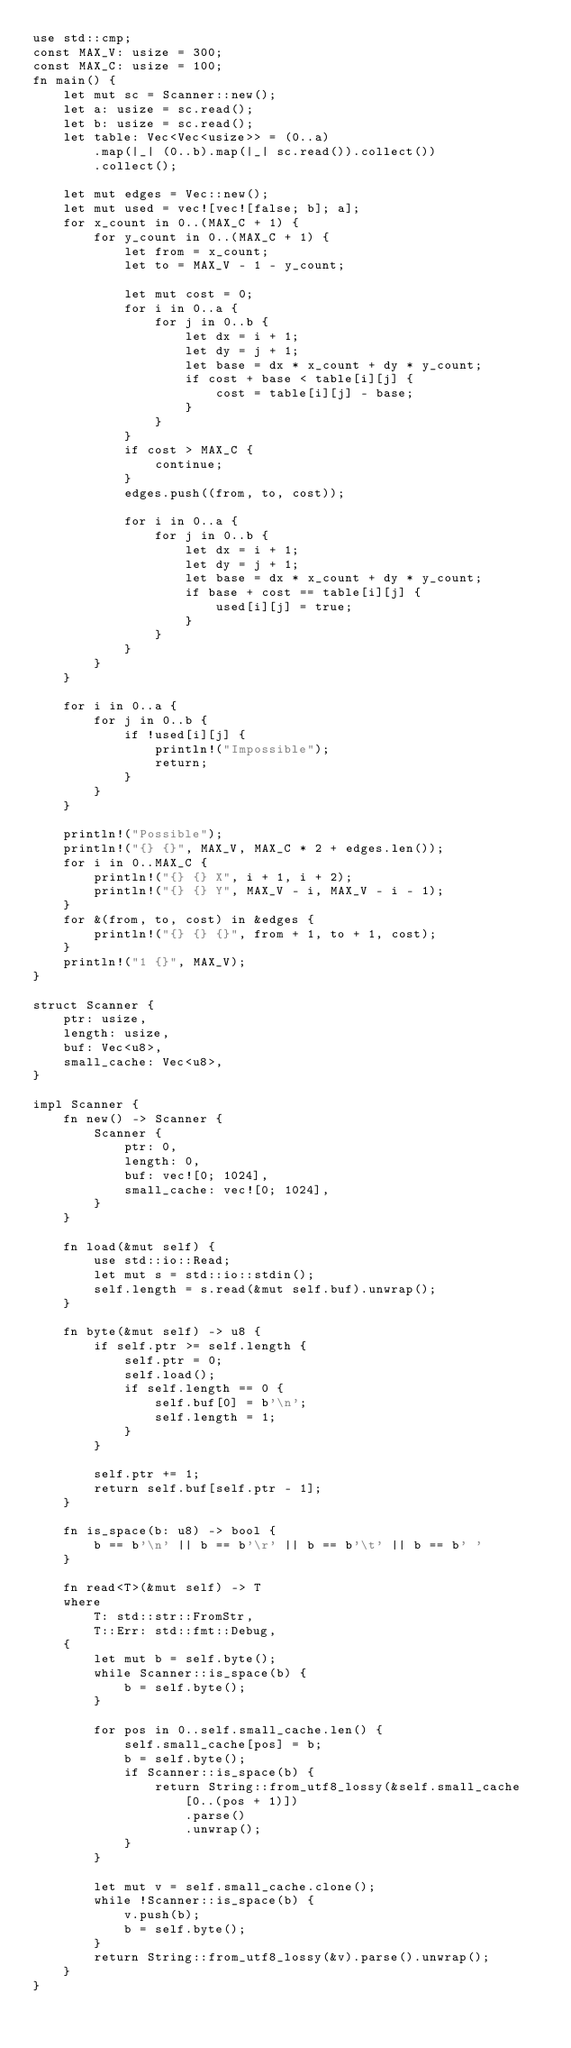Convert code to text. <code><loc_0><loc_0><loc_500><loc_500><_Rust_>use std::cmp;
const MAX_V: usize = 300;
const MAX_C: usize = 100;
fn main() {
    let mut sc = Scanner::new();
    let a: usize = sc.read();
    let b: usize = sc.read();
    let table: Vec<Vec<usize>> = (0..a)
        .map(|_| (0..b).map(|_| sc.read()).collect())
        .collect();

    let mut edges = Vec::new();
    let mut used = vec![vec![false; b]; a];
    for x_count in 0..(MAX_C + 1) {
        for y_count in 0..(MAX_C + 1) {
            let from = x_count;
            let to = MAX_V - 1 - y_count;

            let mut cost = 0;
            for i in 0..a {
                for j in 0..b {
                    let dx = i + 1;
                    let dy = j + 1;
                    let base = dx * x_count + dy * y_count;
                    if cost + base < table[i][j] {
                        cost = table[i][j] - base;
                    }
                }
            }
            if cost > MAX_C {
                continue;
            }
            edges.push((from, to, cost));

            for i in 0..a {
                for j in 0..b {
                    let dx = i + 1;
                    let dy = j + 1;
                    let base = dx * x_count + dy * y_count;
                    if base + cost == table[i][j] {
                        used[i][j] = true;
                    }
                }
            }
        }
    }

    for i in 0..a {
        for j in 0..b {
            if !used[i][j] {
                println!("Impossible");
                return;
            }
        }
    }

    println!("Possible");
    println!("{} {}", MAX_V, MAX_C * 2 + edges.len());
    for i in 0..MAX_C {
        println!("{} {} X", i + 1, i + 2);
        println!("{} {} Y", MAX_V - i, MAX_V - i - 1);
    }
    for &(from, to, cost) in &edges {
        println!("{} {} {}", from + 1, to + 1, cost);
    }
    println!("1 {}", MAX_V);
}

struct Scanner {
    ptr: usize,
    length: usize,
    buf: Vec<u8>,
    small_cache: Vec<u8>,
}

impl Scanner {
    fn new() -> Scanner {
        Scanner {
            ptr: 0,
            length: 0,
            buf: vec![0; 1024],
            small_cache: vec![0; 1024],
        }
    }

    fn load(&mut self) {
        use std::io::Read;
        let mut s = std::io::stdin();
        self.length = s.read(&mut self.buf).unwrap();
    }

    fn byte(&mut self) -> u8 {
        if self.ptr >= self.length {
            self.ptr = 0;
            self.load();
            if self.length == 0 {
                self.buf[0] = b'\n';
                self.length = 1;
            }
        }

        self.ptr += 1;
        return self.buf[self.ptr - 1];
    }

    fn is_space(b: u8) -> bool {
        b == b'\n' || b == b'\r' || b == b'\t' || b == b' '
    }

    fn read<T>(&mut self) -> T
    where
        T: std::str::FromStr,
        T::Err: std::fmt::Debug,
    {
        let mut b = self.byte();
        while Scanner::is_space(b) {
            b = self.byte();
        }

        for pos in 0..self.small_cache.len() {
            self.small_cache[pos] = b;
            b = self.byte();
            if Scanner::is_space(b) {
                return String::from_utf8_lossy(&self.small_cache[0..(pos + 1)])
                    .parse()
                    .unwrap();
            }
        }

        let mut v = self.small_cache.clone();
        while !Scanner::is_space(b) {
            v.push(b);
            b = self.byte();
        }
        return String::from_utf8_lossy(&v).parse().unwrap();
    }
}
</code> 